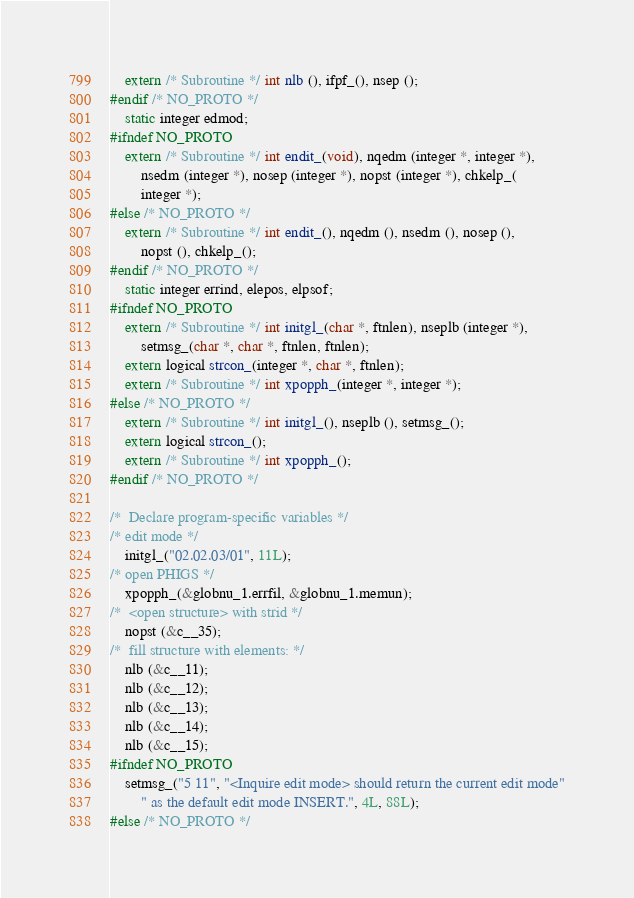<code> <loc_0><loc_0><loc_500><loc_500><_C_>    extern /* Subroutine */ int nlb (), ifpf_(), nsep ();
#endif /* NO_PROTO */
    static integer edmod;
#ifndef NO_PROTO
    extern /* Subroutine */ int endit_(void), nqedm (integer *, integer *), 
	    nsedm (integer *), nosep (integer *), nopst (integer *), chkelp_(
	    integer *);
#else /* NO_PROTO */
    extern /* Subroutine */ int endit_(), nqedm (), nsedm (), nosep (), 
	    nopst (), chkelp_();
#endif /* NO_PROTO */
    static integer errind, elepos, elpsof;
#ifndef NO_PROTO
    extern /* Subroutine */ int initgl_(char *, ftnlen), nseplb (integer *), 
	    setmsg_(char *, char *, ftnlen, ftnlen);
    extern logical strcon_(integer *, char *, ftnlen);
    extern /* Subroutine */ int xpopph_(integer *, integer *);
#else /* NO_PROTO */
    extern /* Subroutine */ int initgl_(), nseplb (), setmsg_();
    extern logical strcon_();
    extern /* Subroutine */ int xpopph_();
#endif /* NO_PROTO */

/*  Declare program-specific variables */
/* edit mode */
    initgl_("02.02.03/01", 11L);
/* open PHIGS */
    xpopph_(&globnu_1.errfil, &globnu_1.memun);
/*  <open structure> with strid */
    nopst (&c__35);
/*  fill structure with elements: */
    nlb (&c__11);
    nlb (&c__12);
    nlb (&c__13);
    nlb (&c__14);
    nlb (&c__15);
#ifndef NO_PROTO
    setmsg_("5 11", "<Inquire edit mode> should return the current edit mode"
	    " as the default edit mode INSERT.", 4L, 88L);
#else /* NO_PROTO */</code> 